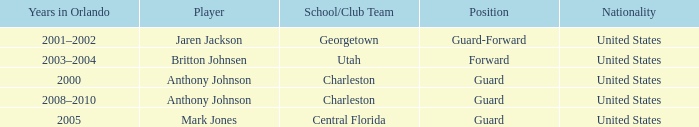Who was the sportsperson residing in orlando in 2005? Mark Jones. 